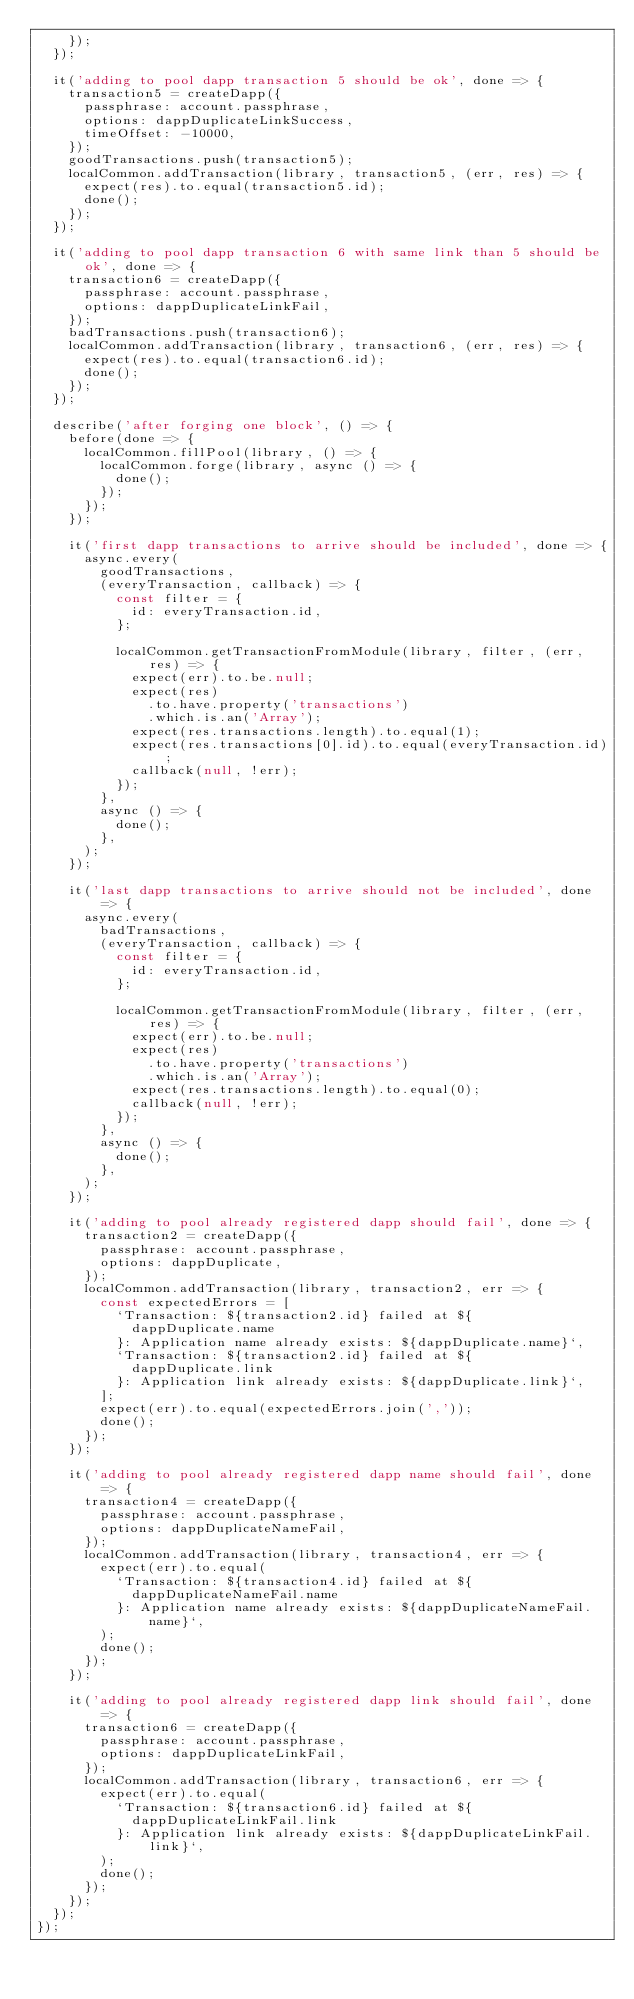<code> <loc_0><loc_0><loc_500><loc_500><_JavaScript_>		});
	});

	it('adding to pool dapp transaction 5 should be ok', done => {
		transaction5 = createDapp({
			passphrase: account.passphrase,
			options: dappDuplicateLinkSuccess,
			timeOffset: -10000,
		});
		goodTransactions.push(transaction5);
		localCommon.addTransaction(library, transaction5, (err, res) => {
			expect(res).to.equal(transaction5.id);
			done();
		});
	});

	it('adding to pool dapp transaction 6 with same link than 5 should be ok', done => {
		transaction6 = createDapp({
			passphrase: account.passphrase,
			options: dappDuplicateLinkFail,
		});
		badTransactions.push(transaction6);
		localCommon.addTransaction(library, transaction6, (err, res) => {
			expect(res).to.equal(transaction6.id);
			done();
		});
	});

	describe('after forging one block', () => {
		before(done => {
			localCommon.fillPool(library, () => {
				localCommon.forge(library, async () => {
					done();
				});
			});
		});

		it('first dapp transactions to arrive should be included', done => {
			async.every(
				goodTransactions,
				(everyTransaction, callback) => {
					const filter = {
						id: everyTransaction.id,
					};

					localCommon.getTransactionFromModule(library, filter, (err, res) => {
						expect(err).to.be.null;
						expect(res)
							.to.have.property('transactions')
							.which.is.an('Array');
						expect(res.transactions.length).to.equal(1);
						expect(res.transactions[0].id).to.equal(everyTransaction.id);
						callback(null, !err);
					});
				},
				async () => {
					done();
				},
			);
		});

		it('last dapp transactions to arrive should not be included', done => {
			async.every(
				badTransactions,
				(everyTransaction, callback) => {
					const filter = {
						id: everyTransaction.id,
					};

					localCommon.getTransactionFromModule(library, filter, (err, res) => {
						expect(err).to.be.null;
						expect(res)
							.to.have.property('transactions')
							.which.is.an('Array');
						expect(res.transactions.length).to.equal(0);
						callback(null, !err);
					});
				},
				async () => {
					done();
				},
			);
		});

		it('adding to pool already registered dapp should fail', done => {
			transaction2 = createDapp({
				passphrase: account.passphrase,
				options: dappDuplicate,
			});
			localCommon.addTransaction(library, transaction2, err => {
				const expectedErrors = [
					`Transaction: ${transaction2.id} failed at ${
						dappDuplicate.name
					}: Application name already exists: ${dappDuplicate.name}`,
					`Transaction: ${transaction2.id} failed at ${
						dappDuplicate.link
					}: Application link already exists: ${dappDuplicate.link}`,
				];
				expect(err).to.equal(expectedErrors.join(','));
				done();
			});
		});

		it('adding to pool already registered dapp name should fail', done => {
			transaction4 = createDapp({
				passphrase: account.passphrase,
				options: dappDuplicateNameFail,
			});
			localCommon.addTransaction(library, transaction4, err => {
				expect(err).to.equal(
					`Transaction: ${transaction4.id} failed at ${
						dappDuplicateNameFail.name
					}: Application name already exists: ${dappDuplicateNameFail.name}`,
				);
				done();
			});
		});

		it('adding to pool already registered dapp link should fail', done => {
			transaction6 = createDapp({
				passphrase: account.passphrase,
				options: dappDuplicateLinkFail,
			});
			localCommon.addTransaction(library, transaction6, err => {
				expect(err).to.equal(
					`Transaction: ${transaction6.id} failed at ${
						dappDuplicateLinkFail.link
					}: Application link already exists: ${dappDuplicateLinkFail.link}`,
				);
				done();
			});
		});
	});
});
</code> 